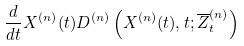<formula> <loc_0><loc_0><loc_500><loc_500>\frac { d } { d t } X ^ { \left ( n \right ) } ( t ) D ^ { ( n ) } \left ( X ^ { ( n ) } ( t ) , t ; \overline { Z } ^ { ( n ) } _ { t } \right )</formula> 